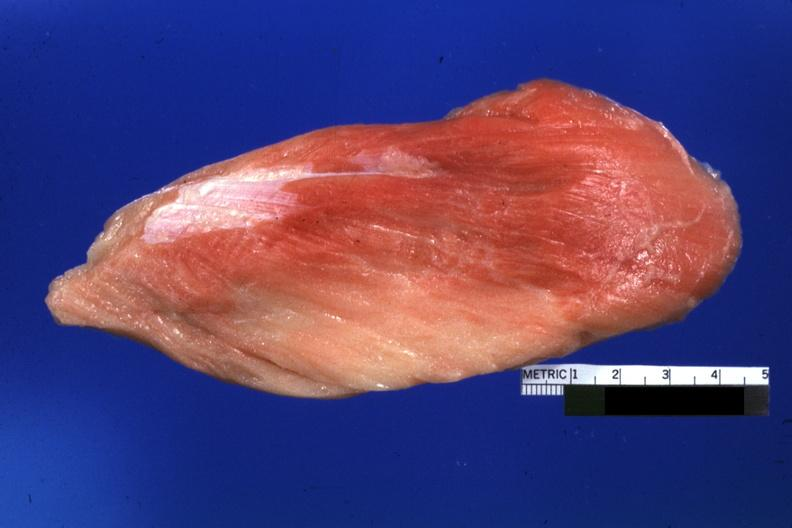what does this image show?
Answer the question using a single word or phrase. Close-up of muscle with some red persisting 